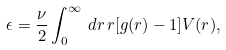Convert formula to latex. <formula><loc_0><loc_0><loc_500><loc_500>\epsilon = \frac { \nu } { 2 } \int _ { 0 } ^ { \infty } \, d r \, r [ g ( r ) - 1 ] V ( r ) ,</formula> 